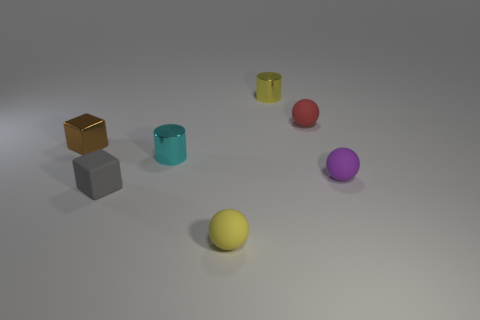Subtract all tiny yellow matte balls. How many balls are left? 2 Add 1 small red spheres. How many objects exist? 8 Subtract all blocks. How many objects are left? 5 Add 4 small yellow metallic cylinders. How many small yellow metallic cylinders are left? 5 Add 6 small yellow cylinders. How many small yellow cylinders exist? 7 Subtract 0 green spheres. How many objects are left? 7 Subtract all cyan things. Subtract all purple balls. How many objects are left? 5 